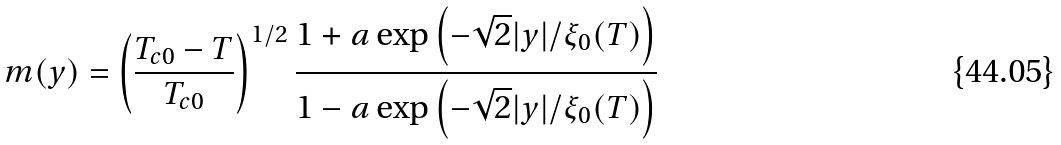<formula> <loc_0><loc_0><loc_500><loc_500>m ( y ) = \left ( \frac { T _ { c 0 } - T } { T _ { c 0 } } \right ) ^ { 1 / 2 } \frac { 1 + a \exp \left ( - \sqrt { 2 } | y | / \xi _ { 0 } ( T ) \right ) } { 1 - a \exp { \left ( - \sqrt { 2 } | y | / \xi _ { 0 } ( T ) \right ) } }</formula> 